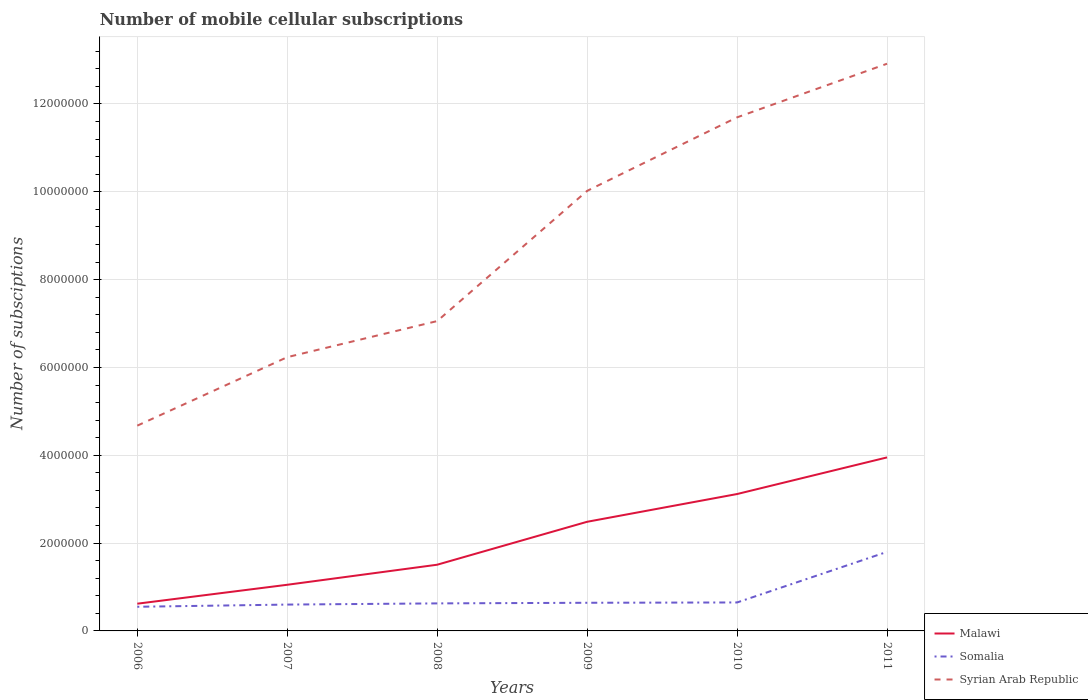How many different coloured lines are there?
Your answer should be very brief. 3. Does the line corresponding to Somalia intersect with the line corresponding to Syrian Arab Republic?
Give a very brief answer. No. Across all years, what is the maximum number of mobile cellular subscriptions in Somalia?
Provide a succinct answer. 5.50e+05. What is the total number of mobile cellular subscriptions in Syrian Arab Republic in the graph?
Provide a succinct answer. -2.38e+06. What is the difference between the highest and the second highest number of mobile cellular subscriptions in Syrian Arab Republic?
Your response must be concise. 8.24e+06. What is the difference between the highest and the lowest number of mobile cellular subscriptions in Syrian Arab Republic?
Provide a short and direct response. 3. How many lines are there?
Give a very brief answer. 3. How many years are there in the graph?
Give a very brief answer. 6. Does the graph contain any zero values?
Ensure brevity in your answer.  No. Where does the legend appear in the graph?
Keep it short and to the point. Bottom right. How many legend labels are there?
Keep it short and to the point. 3. How are the legend labels stacked?
Your answer should be very brief. Vertical. What is the title of the graph?
Ensure brevity in your answer.  Number of mobile cellular subscriptions. What is the label or title of the X-axis?
Your answer should be very brief. Years. What is the label or title of the Y-axis?
Provide a succinct answer. Number of subsciptions. What is the Number of subsciptions in Malawi in 2006?
Keep it short and to the point. 6.20e+05. What is the Number of subsciptions in Somalia in 2006?
Keep it short and to the point. 5.50e+05. What is the Number of subsciptions of Syrian Arab Republic in 2006?
Your answer should be compact. 4.68e+06. What is the Number of subsciptions of Malawi in 2007?
Keep it short and to the point. 1.05e+06. What is the Number of subsciptions of Syrian Arab Republic in 2007?
Make the answer very short. 6.23e+06. What is the Number of subsciptions of Malawi in 2008?
Your answer should be compact. 1.51e+06. What is the Number of subsciptions in Somalia in 2008?
Provide a succinct answer. 6.27e+05. What is the Number of subsciptions of Syrian Arab Republic in 2008?
Provide a short and direct response. 7.06e+06. What is the Number of subsciptions of Malawi in 2009?
Your answer should be very brief. 2.49e+06. What is the Number of subsciptions in Somalia in 2009?
Ensure brevity in your answer.  6.41e+05. What is the Number of subsciptions in Syrian Arab Republic in 2009?
Your response must be concise. 1.00e+07. What is the Number of subsciptions of Malawi in 2010?
Provide a short and direct response. 3.12e+06. What is the Number of subsciptions in Somalia in 2010?
Offer a terse response. 6.48e+05. What is the Number of subsciptions in Syrian Arab Republic in 2010?
Offer a very short reply. 1.17e+07. What is the Number of subsciptions in Malawi in 2011?
Your answer should be compact. 3.95e+06. What is the Number of subsciptions of Somalia in 2011?
Your answer should be compact. 1.80e+06. What is the Number of subsciptions in Syrian Arab Republic in 2011?
Your answer should be compact. 1.29e+07. Across all years, what is the maximum Number of subsciptions in Malawi?
Your answer should be compact. 3.95e+06. Across all years, what is the maximum Number of subsciptions in Somalia?
Your response must be concise. 1.80e+06. Across all years, what is the maximum Number of subsciptions of Syrian Arab Republic?
Your answer should be compact. 1.29e+07. Across all years, what is the minimum Number of subsciptions in Malawi?
Give a very brief answer. 6.20e+05. Across all years, what is the minimum Number of subsciptions in Syrian Arab Republic?
Your answer should be very brief. 4.68e+06. What is the total Number of subsciptions in Malawi in the graph?
Your answer should be compact. 1.27e+07. What is the total Number of subsciptions in Somalia in the graph?
Make the answer very short. 4.87e+06. What is the total Number of subsciptions in Syrian Arab Republic in the graph?
Ensure brevity in your answer.  5.26e+07. What is the difference between the Number of subsciptions of Malawi in 2006 and that in 2007?
Your response must be concise. -4.31e+05. What is the difference between the Number of subsciptions in Syrian Arab Republic in 2006 and that in 2007?
Make the answer very short. -1.56e+06. What is the difference between the Number of subsciptions of Malawi in 2006 and that in 2008?
Ensure brevity in your answer.  -8.88e+05. What is the difference between the Number of subsciptions of Somalia in 2006 and that in 2008?
Provide a short and direct response. -7.70e+04. What is the difference between the Number of subsciptions in Syrian Arab Republic in 2006 and that in 2008?
Keep it short and to the point. -2.38e+06. What is the difference between the Number of subsciptions in Malawi in 2006 and that in 2009?
Give a very brief answer. -1.87e+06. What is the difference between the Number of subsciptions in Somalia in 2006 and that in 2009?
Ensure brevity in your answer.  -9.10e+04. What is the difference between the Number of subsciptions of Syrian Arab Republic in 2006 and that in 2009?
Your answer should be very brief. -5.35e+06. What is the difference between the Number of subsciptions in Malawi in 2006 and that in 2010?
Give a very brief answer. -2.50e+06. What is the difference between the Number of subsciptions of Somalia in 2006 and that in 2010?
Offer a terse response. -9.82e+04. What is the difference between the Number of subsciptions of Syrian Arab Republic in 2006 and that in 2010?
Your answer should be very brief. -7.02e+06. What is the difference between the Number of subsciptions of Malawi in 2006 and that in 2011?
Your response must be concise. -3.33e+06. What is the difference between the Number of subsciptions in Somalia in 2006 and that in 2011?
Offer a very short reply. -1.25e+06. What is the difference between the Number of subsciptions of Syrian Arab Republic in 2006 and that in 2011?
Your response must be concise. -8.24e+06. What is the difference between the Number of subsciptions of Malawi in 2007 and that in 2008?
Make the answer very short. -4.57e+05. What is the difference between the Number of subsciptions of Somalia in 2007 and that in 2008?
Give a very brief answer. -2.70e+04. What is the difference between the Number of subsciptions in Syrian Arab Republic in 2007 and that in 2008?
Make the answer very short. -8.21e+05. What is the difference between the Number of subsciptions in Malawi in 2007 and that in 2009?
Ensure brevity in your answer.  -1.43e+06. What is the difference between the Number of subsciptions in Somalia in 2007 and that in 2009?
Give a very brief answer. -4.10e+04. What is the difference between the Number of subsciptions of Syrian Arab Republic in 2007 and that in 2009?
Your answer should be compact. -3.79e+06. What is the difference between the Number of subsciptions of Malawi in 2007 and that in 2010?
Ensure brevity in your answer.  -2.07e+06. What is the difference between the Number of subsciptions in Somalia in 2007 and that in 2010?
Provide a succinct answer. -4.82e+04. What is the difference between the Number of subsciptions of Syrian Arab Republic in 2007 and that in 2010?
Your answer should be very brief. -5.46e+06. What is the difference between the Number of subsciptions in Malawi in 2007 and that in 2011?
Your answer should be very brief. -2.90e+06. What is the difference between the Number of subsciptions in Somalia in 2007 and that in 2011?
Give a very brief answer. -1.20e+06. What is the difference between the Number of subsciptions of Syrian Arab Republic in 2007 and that in 2011?
Make the answer very short. -6.68e+06. What is the difference between the Number of subsciptions in Malawi in 2008 and that in 2009?
Your response must be concise. -9.78e+05. What is the difference between the Number of subsciptions of Somalia in 2008 and that in 2009?
Your answer should be compact. -1.40e+04. What is the difference between the Number of subsciptions of Syrian Arab Republic in 2008 and that in 2009?
Ensure brevity in your answer.  -2.97e+06. What is the difference between the Number of subsciptions of Malawi in 2008 and that in 2010?
Ensure brevity in your answer.  -1.61e+06. What is the difference between the Number of subsciptions in Somalia in 2008 and that in 2010?
Your answer should be very brief. -2.12e+04. What is the difference between the Number of subsciptions of Syrian Arab Republic in 2008 and that in 2010?
Provide a succinct answer. -4.64e+06. What is the difference between the Number of subsciptions in Malawi in 2008 and that in 2011?
Your response must be concise. -2.44e+06. What is the difference between the Number of subsciptions in Somalia in 2008 and that in 2011?
Offer a terse response. -1.17e+06. What is the difference between the Number of subsciptions of Syrian Arab Republic in 2008 and that in 2011?
Your answer should be compact. -5.86e+06. What is the difference between the Number of subsciptions in Malawi in 2009 and that in 2010?
Your response must be concise. -6.32e+05. What is the difference between the Number of subsciptions in Somalia in 2009 and that in 2010?
Provide a succinct answer. -7200. What is the difference between the Number of subsciptions in Syrian Arab Republic in 2009 and that in 2010?
Offer a very short reply. -1.67e+06. What is the difference between the Number of subsciptions in Malawi in 2009 and that in 2011?
Keep it short and to the point. -1.47e+06. What is the difference between the Number of subsciptions of Somalia in 2009 and that in 2011?
Provide a succinct answer. -1.16e+06. What is the difference between the Number of subsciptions in Syrian Arab Republic in 2009 and that in 2011?
Offer a terse response. -2.90e+06. What is the difference between the Number of subsciptions in Malawi in 2010 and that in 2011?
Make the answer very short. -8.34e+05. What is the difference between the Number of subsciptions of Somalia in 2010 and that in 2011?
Offer a very short reply. -1.15e+06. What is the difference between the Number of subsciptions in Syrian Arab Republic in 2010 and that in 2011?
Your response must be concise. -1.22e+06. What is the difference between the Number of subsciptions in Malawi in 2006 and the Number of subsciptions in Somalia in 2007?
Offer a terse response. 2.02e+04. What is the difference between the Number of subsciptions of Malawi in 2006 and the Number of subsciptions of Syrian Arab Republic in 2007?
Your answer should be compact. -5.61e+06. What is the difference between the Number of subsciptions in Somalia in 2006 and the Number of subsciptions in Syrian Arab Republic in 2007?
Offer a very short reply. -5.68e+06. What is the difference between the Number of subsciptions of Malawi in 2006 and the Number of subsciptions of Somalia in 2008?
Your answer should be very brief. -6837. What is the difference between the Number of subsciptions of Malawi in 2006 and the Number of subsciptions of Syrian Arab Republic in 2008?
Give a very brief answer. -6.44e+06. What is the difference between the Number of subsciptions of Somalia in 2006 and the Number of subsciptions of Syrian Arab Republic in 2008?
Keep it short and to the point. -6.51e+06. What is the difference between the Number of subsciptions of Malawi in 2006 and the Number of subsciptions of Somalia in 2009?
Provide a short and direct response. -2.08e+04. What is the difference between the Number of subsciptions in Malawi in 2006 and the Number of subsciptions in Syrian Arab Republic in 2009?
Offer a terse response. -9.40e+06. What is the difference between the Number of subsciptions in Somalia in 2006 and the Number of subsciptions in Syrian Arab Republic in 2009?
Provide a short and direct response. -9.47e+06. What is the difference between the Number of subsciptions of Malawi in 2006 and the Number of subsciptions of Somalia in 2010?
Provide a succinct answer. -2.80e+04. What is the difference between the Number of subsciptions of Malawi in 2006 and the Number of subsciptions of Syrian Arab Republic in 2010?
Offer a terse response. -1.11e+07. What is the difference between the Number of subsciptions of Somalia in 2006 and the Number of subsciptions of Syrian Arab Republic in 2010?
Offer a terse response. -1.11e+07. What is the difference between the Number of subsciptions in Malawi in 2006 and the Number of subsciptions in Somalia in 2011?
Your response must be concise. -1.18e+06. What is the difference between the Number of subsciptions of Malawi in 2006 and the Number of subsciptions of Syrian Arab Republic in 2011?
Your answer should be compact. -1.23e+07. What is the difference between the Number of subsciptions in Somalia in 2006 and the Number of subsciptions in Syrian Arab Republic in 2011?
Offer a terse response. -1.24e+07. What is the difference between the Number of subsciptions in Malawi in 2007 and the Number of subsciptions in Somalia in 2008?
Keep it short and to the point. 4.24e+05. What is the difference between the Number of subsciptions of Malawi in 2007 and the Number of subsciptions of Syrian Arab Republic in 2008?
Offer a very short reply. -6.01e+06. What is the difference between the Number of subsciptions in Somalia in 2007 and the Number of subsciptions in Syrian Arab Republic in 2008?
Ensure brevity in your answer.  -6.46e+06. What is the difference between the Number of subsciptions of Malawi in 2007 and the Number of subsciptions of Somalia in 2009?
Your response must be concise. 4.10e+05. What is the difference between the Number of subsciptions in Malawi in 2007 and the Number of subsciptions in Syrian Arab Republic in 2009?
Ensure brevity in your answer.  -8.97e+06. What is the difference between the Number of subsciptions in Somalia in 2007 and the Number of subsciptions in Syrian Arab Republic in 2009?
Give a very brief answer. -9.42e+06. What is the difference between the Number of subsciptions in Malawi in 2007 and the Number of subsciptions in Somalia in 2010?
Give a very brief answer. 4.03e+05. What is the difference between the Number of subsciptions in Malawi in 2007 and the Number of subsciptions in Syrian Arab Republic in 2010?
Your answer should be very brief. -1.06e+07. What is the difference between the Number of subsciptions in Somalia in 2007 and the Number of subsciptions in Syrian Arab Republic in 2010?
Your response must be concise. -1.11e+07. What is the difference between the Number of subsciptions in Malawi in 2007 and the Number of subsciptions in Somalia in 2011?
Provide a short and direct response. -7.49e+05. What is the difference between the Number of subsciptions of Malawi in 2007 and the Number of subsciptions of Syrian Arab Republic in 2011?
Ensure brevity in your answer.  -1.19e+07. What is the difference between the Number of subsciptions of Somalia in 2007 and the Number of subsciptions of Syrian Arab Republic in 2011?
Offer a terse response. -1.23e+07. What is the difference between the Number of subsciptions in Malawi in 2008 and the Number of subsciptions in Somalia in 2009?
Your answer should be compact. 8.67e+05. What is the difference between the Number of subsciptions of Malawi in 2008 and the Number of subsciptions of Syrian Arab Republic in 2009?
Provide a short and direct response. -8.51e+06. What is the difference between the Number of subsciptions of Somalia in 2008 and the Number of subsciptions of Syrian Arab Republic in 2009?
Your answer should be compact. -9.39e+06. What is the difference between the Number of subsciptions in Malawi in 2008 and the Number of subsciptions in Somalia in 2010?
Your answer should be very brief. 8.59e+05. What is the difference between the Number of subsciptions of Malawi in 2008 and the Number of subsciptions of Syrian Arab Republic in 2010?
Provide a succinct answer. -1.02e+07. What is the difference between the Number of subsciptions of Somalia in 2008 and the Number of subsciptions of Syrian Arab Republic in 2010?
Offer a very short reply. -1.11e+07. What is the difference between the Number of subsciptions of Malawi in 2008 and the Number of subsciptions of Somalia in 2011?
Make the answer very short. -2.92e+05. What is the difference between the Number of subsciptions of Malawi in 2008 and the Number of subsciptions of Syrian Arab Republic in 2011?
Offer a very short reply. -1.14e+07. What is the difference between the Number of subsciptions of Somalia in 2008 and the Number of subsciptions of Syrian Arab Republic in 2011?
Provide a short and direct response. -1.23e+07. What is the difference between the Number of subsciptions in Malawi in 2009 and the Number of subsciptions in Somalia in 2010?
Your response must be concise. 1.84e+06. What is the difference between the Number of subsciptions of Malawi in 2009 and the Number of subsciptions of Syrian Arab Republic in 2010?
Your answer should be very brief. -9.21e+06. What is the difference between the Number of subsciptions in Somalia in 2009 and the Number of subsciptions in Syrian Arab Republic in 2010?
Give a very brief answer. -1.11e+07. What is the difference between the Number of subsciptions in Malawi in 2009 and the Number of subsciptions in Somalia in 2011?
Give a very brief answer. 6.86e+05. What is the difference between the Number of subsciptions in Malawi in 2009 and the Number of subsciptions in Syrian Arab Republic in 2011?
Offer a terse response. -1.04e+07. What is the difference between the Number of subsciptions of Somalia in 2009 and the Number of subsciptions of Syrian Arab Republic in 2011?
Offer a terse response. -1.23e+07. What is the difference between the Number of subsciptions in Malawi in 2010 and the Number of subsciptions in Somalia in 2011?
Provide a short and direct response. 1.32e+06. What is the difference between the Number of subsciptions in Malawi in 2010 and the Number of subsciptions in Syrian Arab Republic in 2011?
Offer a very short reply. -9.80e+06. What is the difference between the Number of subsciptions in Somalia in 2010 and the Number of subsciptions in Syrian Arab Republic in 2011?
Make the answer very short. -1.23e+07. What is the average Number of subsciptions of Malawi per year?
Your response must be concise. 2.12e+06. What is the average Number of subsciptions in Somalia per year?
Your response must be concise. 8.11e+05. What is the average Number of subsciptions of Syrian Arab Republic per year?
Make the answer very short. 8.77e+06. In the year 2006, what is the difference between the Number of subsciptions of Malawi and Number of subsciptions of Somalia?
Offer a terse response. 7.02e+04. In the year 2006, what is the difference between the Number of subsciptions in Malawi and Number of subsciptions in Syrian Arab Republic?
Offer a very short reply. -4.05e+06. In the year 2006, what is the difference between the Number of subsciptions of Somalia and Number of subsciptions of Syrian Arab Republic?
Your response must be concise. -4.12e+06. In the year 2007, what is the difference between the Number of subsciptions of Malawi and Number of subsciptions of Somalia?
Offer a very short reply. 4.51e+05. In the year 2007, what is the difference between the Number of subsciptions in Malawi and Number of subsciptions in Syrian Arab Republic?
Provide a succinct answer. -5.18e+06. In the year 2007, what is the difference between the Number of subsciptions in Somalia and Number of subsciptions in Syrian Arab Republic?
Offer a very short reply. -5.63e+06. In the year 2008, what is the difference between the Number of subsciptions in Malawi and Number of subsciptions in Somalia?
Provide a short and direct response. 8.81e+05. In the year 2008, what is the difference between the Number of subsciptions of Malawi and Number of subsciptions of Syrian Arab Republic?
Ensure brevity in your answer.  -5.55e+06. In the year 2008, what is the difference between the Number of subsciptions in Somalia and Number of subsciptions in Syrian Arab Republic?
Offer a terse response. -6.43e+06. In the year 2009, what is the difference between the Number of subsciptions in Malawi and Number of subsciptions in Somalia?
Your answer should be very brief. 1.84e+06. In the year 2009, what is the difference between the Number of subsciptions in Malawi and Number of subsciptions in Syrian Arab Republic?
Make the answer very short. -7.54e+06. In the year 2009, what is the difference between the Number of subsciptions of Somalia and Number of subsciptions of Syrian Arab Republic?
Give a very brief answer. -9.38e+06. In the year 2010, what is the difference between the Number of subsciptions of Malawi and Number of subsciptions of Somalia?
Offer a very short reply. 2.47e+06. In the year 2010, what is the difference between the Number of subsciptions of Malawi and Number of subsciptions of Syrian Arab Republic?
Make the answer very short. -8.58e+06. In the year 2010, what is the difference between the Number of subsciptions in Somalia and Number of subsciptions in Syrian Arab Republic?
Provide a succinct answer. -1.10e+07. In the year 2011, what is the difference between the Number of subsciptions in Malawi and Number of subsciptions in Somalia?
Make the answer very short. 2.15e+06. In the year 2011, what is the difference between the Number of subsciptions of Malawi and Number of subsciptions of Syrian Arab Republic?
Keep it short and to the point. -8.97e+06. In the year 2011, what is the difference between the Number of subsciptions of Somalia and Number of subsciptions of Syrian Arab Republic?
Keep it short and to the point. -1.11e+07. What is the ratio of the Number of subsciptions of Malawi in 2006 to that in 2007?
Make the answer very short. 0.59. What is the ratio of the Number of subsciptions in Syrian Arab Republic in 2006 to that in 2007?
Make the answer very short. 0.75. What is the ratio of the Number of subsciptions in Malawi in 2006 to that in 2008?
Make the answer very short. 0.41. What is the ratio of the Number of subsciptions of Somalia in 2006 to that in 2008?
Make the answer very short. 0.88. What is the ratio of the Number of subsciptions of Syrian Arab Republic in 2006 to that in 2008?
Your response must be concise. 0.66. What is the ratio of the Number of subsciptions in Malawi in 2006 to that in 2009?
Your answer should be compact. 0.25. What is the ratio of the Number of subsciptions of Somalia in 2006 to that in 2009?
Provide a succinct answer. 0.86. What is the ratio of the Number of subsciptions in Syrian Arab Republic in 2006 to that in 2009?
Keep it short and to the point. 0.47. What is the ratio of the Number of subsciptions in Malawi in 2006 to that in 2010?
Offer a terse response. 0.2. What is the ratio of the Number of subsciptions in Somalia in 2006 to that in 2010?
Keep it short and to the point. 0.85. What is the ratio of the Number of subsciptions in Syrian Arab Republic in 2006 to that in 2010?
Offer a terse response. 0.4. What is the ratio of the Number of subsciptions of Malawi in 2006 to that in 2011?
Your answer should be very brief. 0.16. What is the ratio of the Number of subsciptions in Somalia in 2006 to that in 2011?
Ensure brevity in your answer.  0.31. What is the ratio of the Number of subsciptions of Syrian Arab Republic in 2006 to that in 2011?
Your response must be concise. 0.36. What is the ratio of the Number of subsciptions of Malawi in 2007 to that in 2008?
Your answer should be compact. 0.7. What is the ratio of the Number of subsciptions in Somalia in 2007 to that in 2008?
Your answer should be compact. 0.96. What is the ratio of the Number of subsciptions in Syrian Arab Republic in 2007 to that in 2008?
Your response must be concise. 0.88. What is the ratio of the Number of subsciptions in Malawi in 2007 to that in 2009?
Give a very brief answer. 0.42. What is the ratio of the Number of subsciptions of Somalia in 2007 to that in 2009?
Offer a terse response. 0.94. What is the ratio of the Number of subsciptions in Syrian Arab Republic in 2007 to that in 2009?
Offer a very short reply. 0.62. What is the ratio of the Number of subsciptions in Malawi in 2007 to that in 2010?
Give a very brief answer. 0.34. What is the ratio of the Number of subsciptions of Somalia in 2007 to that in 2010?
Provide a succinct answer. 0.93. What is the ratio of the Number of subsciptions of Syrian Arab Republic in 2007 to that in 2010?
Offer a very short reply. 0.53. What is the ratio of the Number of subsciptions of Malawi in 2007 to that in 2011?
Provide a succinct answer. 0.27. What is the ratio of the Number of subsciptions of Syrian Arab Republic in 2007 to that in 2011?
Your answer should be compact. 0.48. What is the ratio of the Number of subsciptions of Malawi in 2008 to that in 2009?
Keep it short and to the point. 0.61. What is the ratio of the Number of subsciptions in Somalia in 2008 to that in 2009?
Provide a short and direct response. 0.98. What is the ratio of the Number of subsciptions of Syrian Arab Republic in 2008 to that in 2009?
Keep it short and to the point. 0.7. What is the ratio of the Number of subsciptions in Malawi in 2008 to that in 2010?
Keep it short and to the point. 0.48. What is the ratio of the Number of subsciptions in Somalia in 2008 to that in 2010?
Ensure brevity in your answer.  0.97. What is the ratio of the Number of subsciptions in Syrian Arab Republic in 2008 to that in 2010?
Offer a terse response. 0.6. What is the ratio of the Number of subsciptions of Malawi in 2008 to that in 2011?
Make the answer very short. 0.38. What is the ratio of the Number of subsciptions in Somalia in 2008 to that in 2011?
Ensure brevity in your answer.  0.35. What is the ratio of the Number of subsciptions in Syrian Arab Republic in 2008 to that in 2011?
Your answer should be very brief. 0.55. What is the ratio of the Number of subsciptions in Malawi in 2009 to that in 2010?
Ensure brevity in your answer.  0.8. What is the ratio of the Number of subsciptions in Somalia in 2009 to that in 2010?
Provide a succinct answer. 0.99. What is the ratio of the Number of subsciptions of Syrian Arab Republic in 2009 to that in 2010?
Your response must be concise. 0.86. What is the ratio of the Number of subsciptions in Malawi in 2009 to that in 2011?
Keep it short and to the point. 0.63. What is the ratio of the Number of subsciptions in Somalia in 2009 to that in 2011?
Ensure brevity in your answer.  0.36. What is the ratio of the Number of subsciptions in Syrian Arab Republic in 2009 to that in 2011?
Provide a succinct answer. 0.78. What is the ratio of the Number of subsciptions in Malawi in 2010 to that in 2011?
Give a very brief answer. 0.79. What is the ratio of the Number of subsciptions in Somalia in 2010 to that in 2011?
Make the answer very short. 0.36. What is the ratio of the Number of subsciptions of Syrian Arab Republic in 2010 to that in 2011?
Provide a succinct answer. 0.91. What is the difference between the highest and the second highest Number of subsciptions of Malawi?
Make the answer very short. 8.34e+05. What is the difference between the highest and the second highest Number of subsciptions in Somalia?
Your answer should be compact. 1.15e+06. What is the difference between the highest and the second highest Number of subsciptions of Syrian Arab Republic?
Ensure brevity in your answer.  1.22e+06. What is the difference between the highest and the lowest Number of subsciptions of Malawi?
Give a very brief answer. 3.33e+06. What is the difference between the highest and the lowest Number of subsciptions of Somalia?
Provide a short and direct response. 1.25e+06. What is the difference between the highest and the lowest Number of subsciptions in Syrian Arab Republic?
Give a very brief answer. 8.24e+06. 